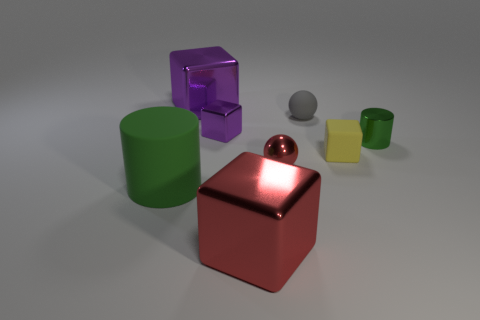Is there a tiny gray sphere that is on the left side of the large metal object in front of the green cylinder behind the red sphere? no 